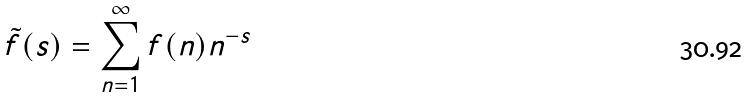<formula> <loc_0><loc_0><loc_500><loc_500>\tilde { f } ( s ) = \sum _ { n = 1 } ^ { \infty } f ( n ) n ^ { - s }</formula> 